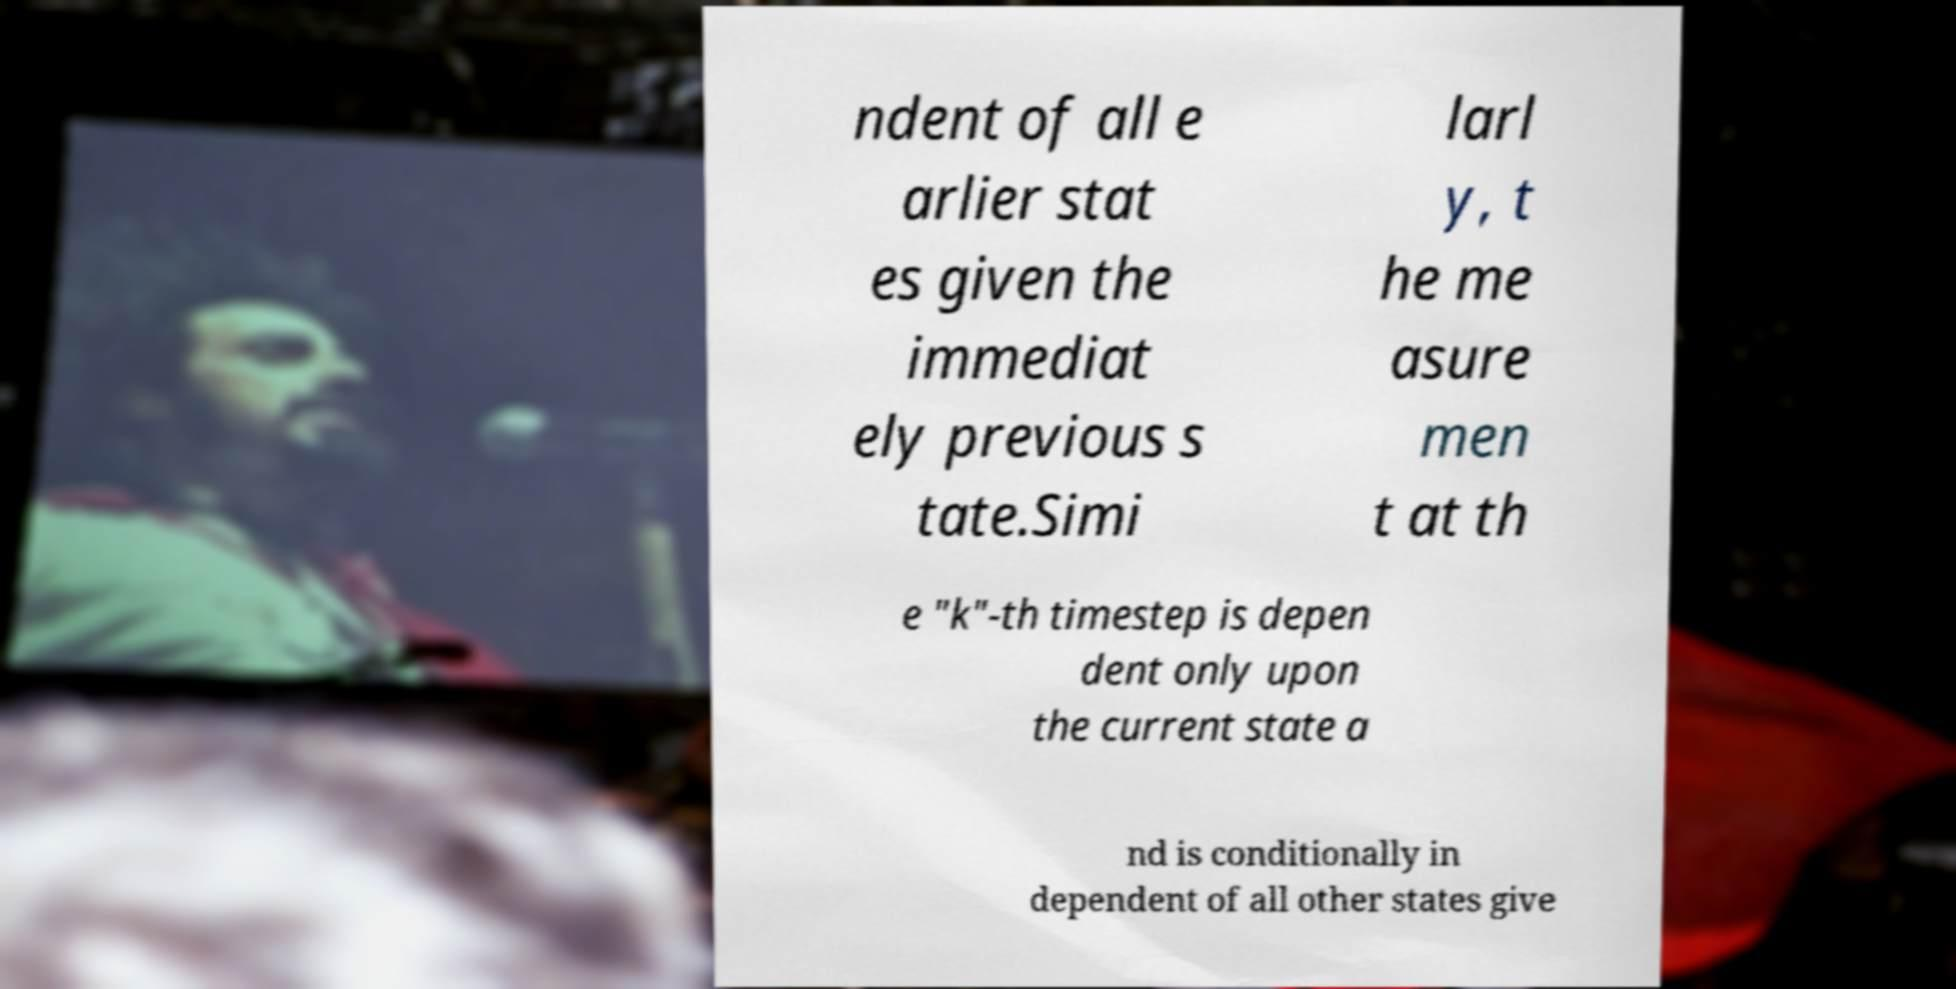I need the written content from this picture converted into text. Can you do that? ndent of all e arlier stat es given the immediat ely previous s tate.Simi larl y, t he me asure men t at th e "k"-th timestep is depen dent only upon the current state a nd is conditionally in dependent of all other states give 